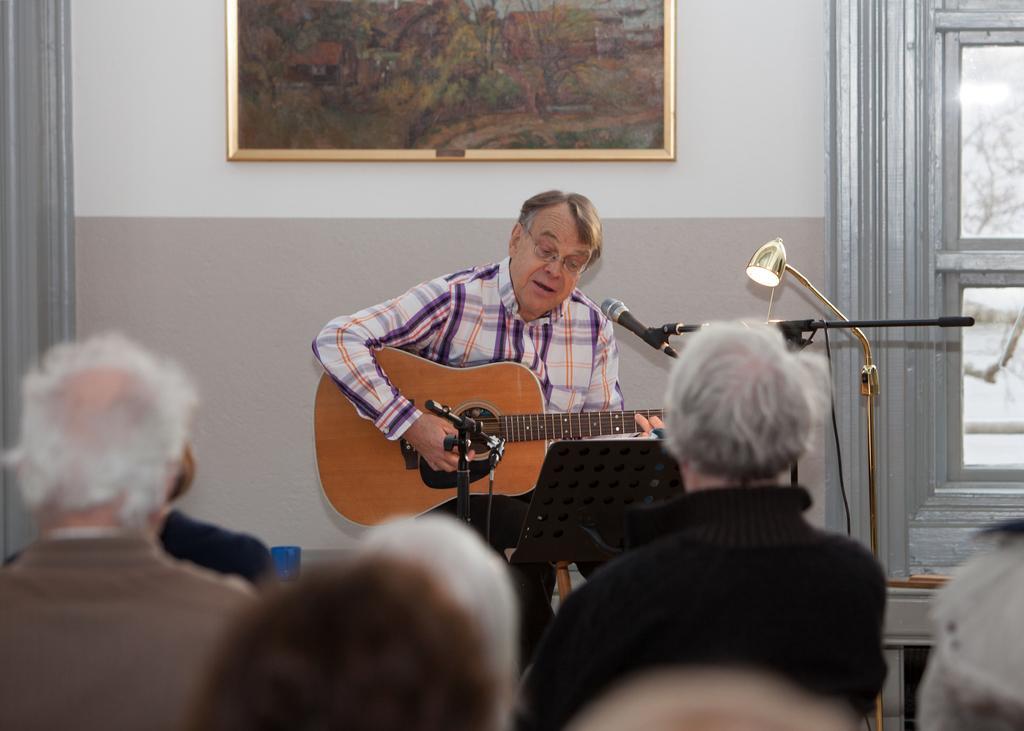How would you summarize this image in a sentence or two? As we can see in the image, there a wall, photo frame, door, light, mike and a man sitting over here and there is a guitar in his hand and there are few people over here. 